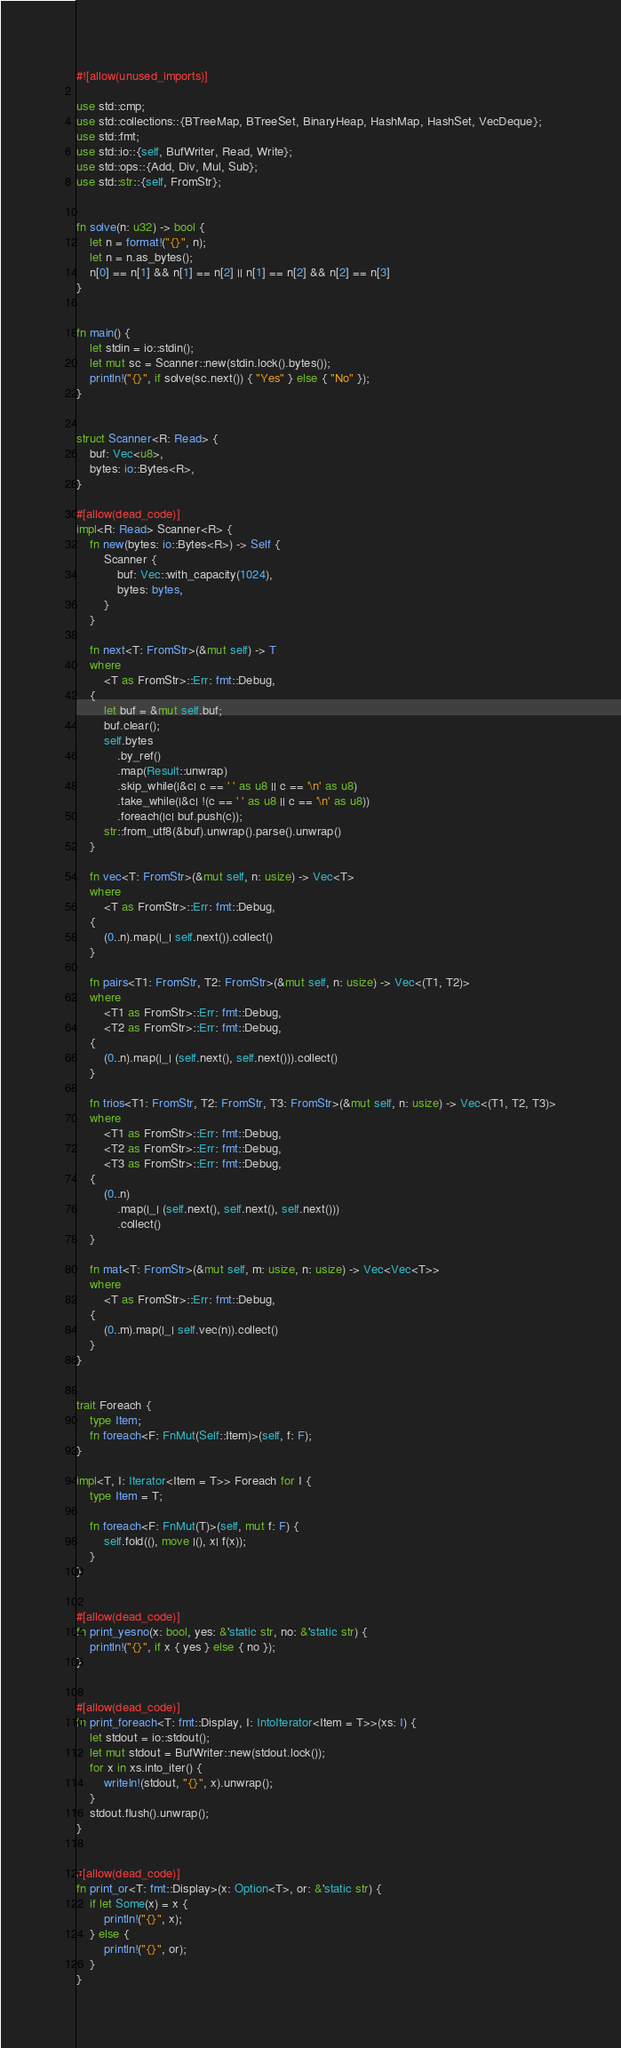<code> <loc_0><loc_0><loc_500><loc_500><_Rust_>#![allow(unused_imports)]

use std::cmp;
use std::collections::{BTreeMap, BTreeSet, BinaryHeap, HashMap, HashSet, VecDeque};
use std::fmt;
use std::io::{self, BufWriter, Read, Write};
use std::ops::{Add, Div, Mul, Sub};
use std::str::{self, FromStr};


fn solve(n: u32) -> bool {
    let n = format!("{}", n);
    let n = n.as_bytes();
    n[0] == n[1] && n[1] == n[2] || n[1] == n[2] && n[2] == n[3]
}


fn main() {
    let stdin = io::stdin();
    let mut sc = Scanner::new(stdin.lock().bytes());
    println!("{}", if solve(sc.next()) { "Yes" } else { "No" });
}


struct Scanner<R: Read> {
    buf: Vec<u8>,
    bytes: io::Bytes<R>,
}

#[allow(dead_code)]
impl<R: Read> Scanner<R> {
    fn new(bytes: io::Bytes<R>) -> Self {
        Scanner {
            buf: Vec::with_capacity(1024),
            bytes: bytes,
        }
    }

    fn next<T: FromStr>(&mut self) -> T
    where
        <T as FromStr>::Err: fmt::Debug,
    {
        let buf = &mut self.buf;
        buf.clear();
        self.bytes
            .by_ref()
            .map(Result::unwrap)
            .skip_while(|&c| c == ' ' as u8 || c == '\n' as u8)
            .take_while(|&c| !(c == ' ' as u8 || c == '\n' as u8))
            .foreach(|c| buf.push(c));
        str::from_utf8(&buf).unwrap().parse().unwrap()
    }

    fn vec<T: FromStr>(&mut self, n: usize) -> Vec<T>
    where
        <T as FromStr>::Err: fmt::Debug,
    {
        (0..n).map(|_| self.next()).collect()
    }

    fn pairs<T1: FromStr, T2: FromStr>(&mut self, n: usize) -> Vec<(T1, T2)>
    where
        <T1 as FromStr>::Err: fmt::Debug,
        <T2 as FromStr>::Err: fmt::Debug,
    {
        (0..n).map(|_| (self.next(), self.next())).collect()
    }

    fn trios<T1: FromStr, T2: FromStr, T3: FromStr>(&mut self, n: usize) -> Vec<(T1, T2, T3)>
    where
        <T1 as FromStr>::Err: fmt::Debug,
        <T2 as FromStr>::Err: fmt::Debug,
        <T3 as FromStr>::Err: fmt::Debug,
    {
        (0..n)
            .map(|_| (self.next(), self.next(), self.next()))
            .collect()
    }

    fn mat<T: FromStr>(&mut self, m: usize, n: usize) -> Vec<Vec<T>>
    where
        <T as FromStr>::Err: fmt::Debug,
    {
        (0..m).map(|_| self.vec(n)).collect()
    }
}


trait Foreach {
    type Item;
    fn foreach<F: FnMut(Self::Item)>(self, f: F);
}

impl<T, I: Iterator<Item = T>> Foreach for I {
    type Item = T;

    fn foreach<F: FnMut(T)>(self, mut f: F) {
        self.fold((), move |(), x| f(x));
    }
}


#[allow(dead_code)]
fn print_yesno(x: bool, yes: &'static str, no: &'static str) {
    println!("{}", if x { yes } else { no });
}


#[allow(dead_code)]
fn print_foreach<T: fmt::Display, I: IntoIterator<Item = T>>(xs: I) {
    let stdout = io::stdout();
    let mut stdout = BufWriter::new(stdout.lock());
    for x in xs.into_iter() {
        writeln!(stdout, "{}", x).unwrap();
    }
    stdout.flush().unwrap();
}


#[allow(dead_code)]
fn print_or<T: fmt::Display>(x: Option<T>, or: &'static str) {
    if let Some(x) = x {
        println!("{}", x);
    } else {
        println!("{}", or);
    }
}
</code> 